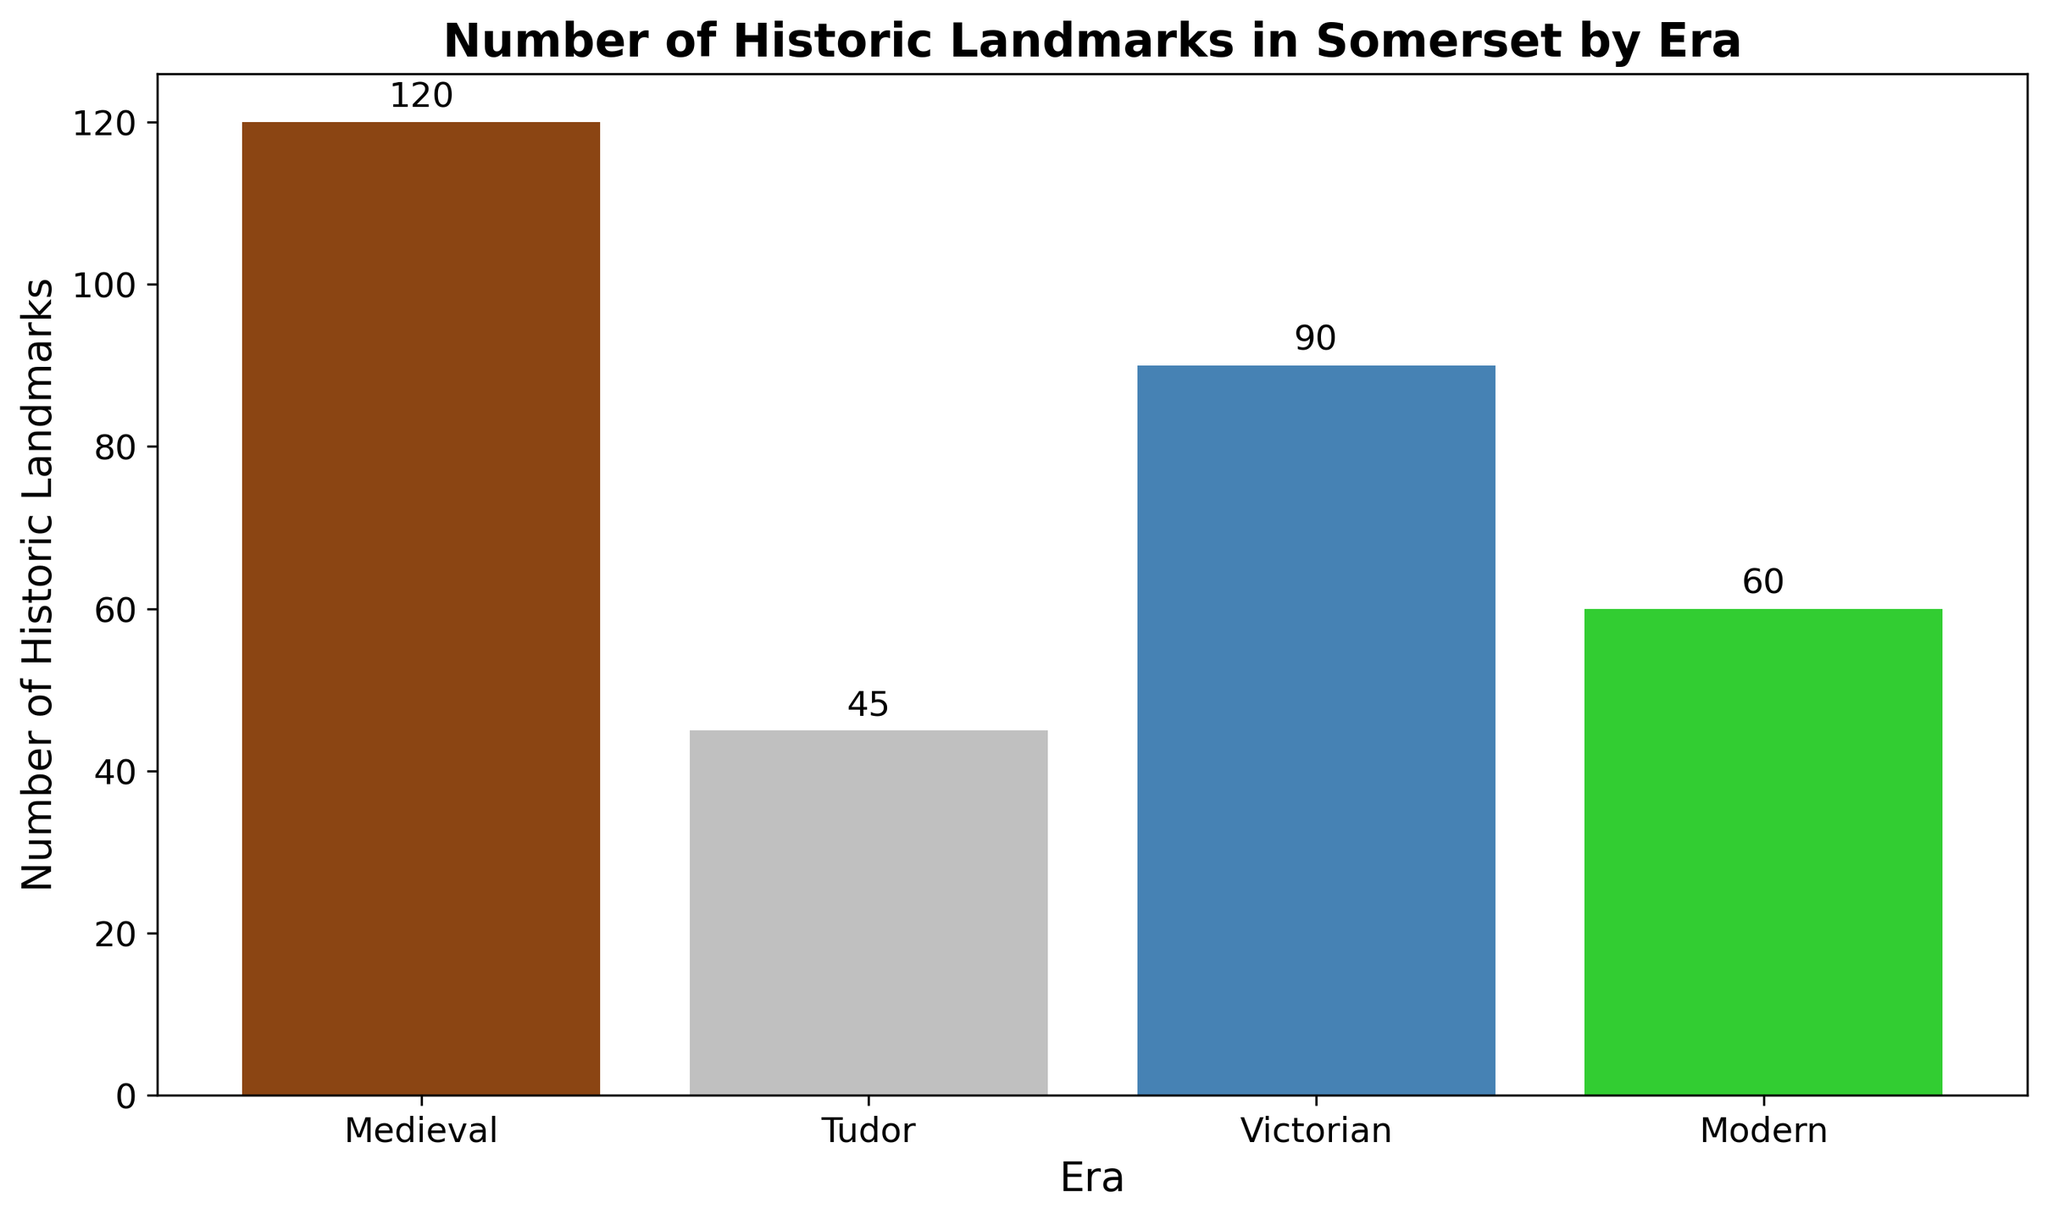What era has the highest number of historic landmarks? The figure shows the tallest bar representing the number of historic landmarks. The tallest bar is in the Medieval era, indicating it has the most landmarks.
Answer: Medieval Which era has the fewest historic landmarks? The figure shows the shortest bar representing the number of historic landmarks. The shortest bar is in the Tudor era, indicating it has the fewest landmarks.
Answer: Tudor How many more historic landmarks are there in the Victorian era compared to the Tudor era? The bar for the Victorian era is at 90 landmarks, and the bar for the Tudor era is at 45 landmarks. The difference is 90 - 45.
Answer: 45 What is the sum of historic landmarks in the Medieval and Modern eras? The number of landmarks in the Medieval era is 120 and in the Modern era is 60. The total is 120 + 60.
Answer: 180 On average, how many historic landmarks are there per era? Sum the number of historic landmarks for all eras: 120 (Medieval) + 45 (Tudor) + 90 (Victorian) + 60 (Modern) = 315. Divide by the number of eras, which is 4: 315 / 4.
Answer: 78.75 Are there more historic landmarks in the Victorian era or the Modern era? The bar representing the Victorian era reaches 90, while the bar for the Modern era reaches 60. 90 is greater than 60.
Answer: Victorian What is the difference in the number of historic landmarks between the era with the greatest number and the era with the fewest? The greatest number of landmarks is 120 (Medieval) and the fewest is 45 (Tudor). The difference is 120 - 45.
Answer: 75 If the number of historic landmarks in each era was doubled, what would be the total number? Double the number of landmarks in each era: 120*2 (Medieval) + 45*2 (Tudor) + 90*2 (Victorian) + 60*2 (Modern) = 240 + 90 + 180 + 120. Sum these values.
Answer: 630 What is the average number of historic landmarks for the Tudor and Victorian eras combined? Sum the number of landmarks for the Tudor (45) and Victorian (90) eras and divide by 2: (45 + 90) / 2.
Answer: 67.5 Which era is represented by the green bar in the figure? The green bar corresponds to the Modern era, as visually identified in the figure.
Answer: Modern 